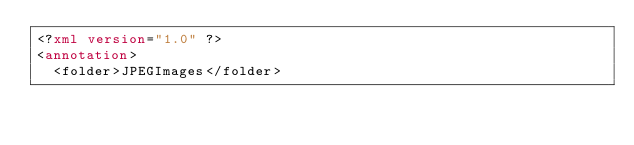<code> <loc_0><loc_0><loc_500><loc_500><_XML_><?xml version="1.0" ?>
<annotation>
	<folder>JPEGImages</folder></code> 